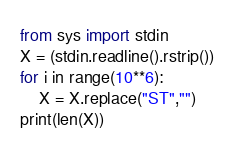Convert code to text. <code><loc_0><loc_0><loc_500><loc_500><_Python_>from sys import stdin
X = (stdin.readline().rstrip())
for i in range(10**6):
    X = X.replace("ST","")
print(len(X))</code> 